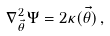Convert formula to latex. <formula><loc_0><loc_0><loc_500><loc_500>\nabla ^ { 2 } _ { \vec { \theta } } \Psi = 2 \kappa ( \vec { \theta } ) \, ,</formula> 